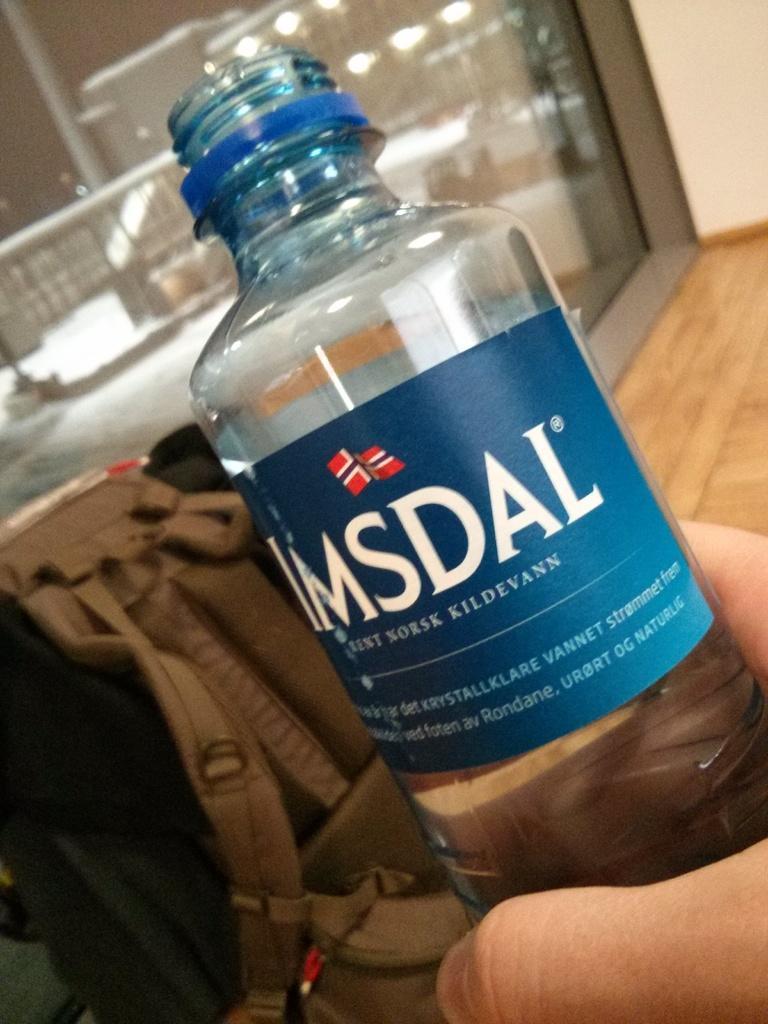How would you summarize this image in a sentence or two? There is a bottle holding by some one and behind that there is a backpack and a glass wall. 